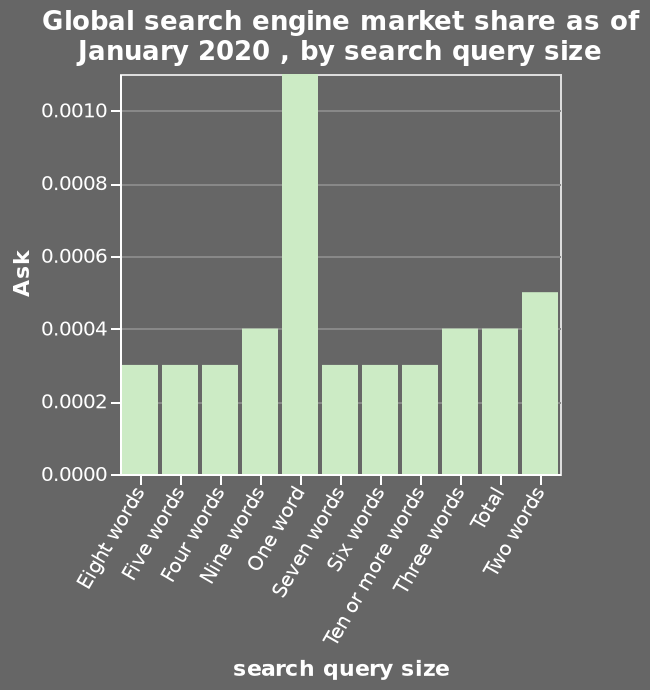<image>
How does the size of the most asked one-word query compare to the next most asked two-word query size?  The most asked one-word query size is over double the height of the next most asked two-word query size. How many categories are there on the x-axis? There are seven categories on the x-axis, starting from Eight words and ending at Two words. What is the time period for which the data is displayed? The data displayed on the graph is as of January 2020. What is the lowest decimal among the query sizes? The lowest decimal among the query sizes is 0.0003. Describe the following image in detail This is a bar graph called Global search engine market share as of January 2020 , by search query size. Along the x-axis, search query size is measured using a categorical scale starting at Eight words and ending at Two words. Ask is drawn on the y-axis. 